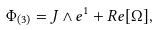Convert formula to latex. <formula><loc_0><loc_0><loc_500><loc_500>\Phi _ { ( 3 ) } = J \wedge e ^ { 1 } + R e [ \Omega ] ,</formula> 